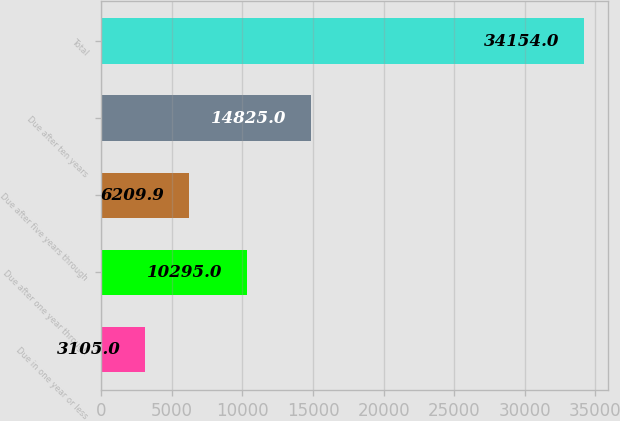Convert chart. <chart><loc_0><loc_0><loc_500><loc_500><bar_chart><fcel>Due in one year or less<fcel>Due after one year through<fcel>Due after five years through<fcel>Due after ten years<fcel>Total<nl><fcel>3105<fcel>10295<fcel>6209.9<fcel>14825<fcel>34154<nl></chart> 